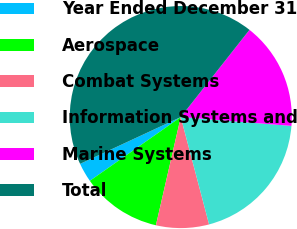<chart> <loc_0><loc_0><loc_500><loc_500><pie_chart><fcel>Year Ended December 31<fcel>Aerospace<fcel>Combat Systems<fcel>Information Systems and<fcel>Marine Systems<fcel>Total<nl><fcel>2.81%<fcel>11.67%<fcel>7.7%<fcel>19.62%<fcel>15.65%<fcel>42.55%<nl></chart> 